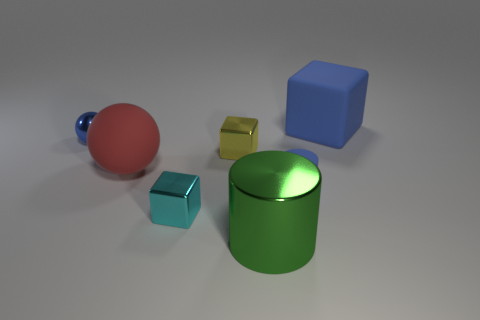Add 2 matte balls. How many objects exist? 9 Subtract all cubes. How many objects are left? 4 Subtract all green metal cylinders. Subtract all blue spheres. How many objects are left? 5 Add 7 metal balls. How many metal balls are left? 8 Add 6 big red things. How many big red things exist? 7 Subtract 0 green spheres. How many objects are left? 7 